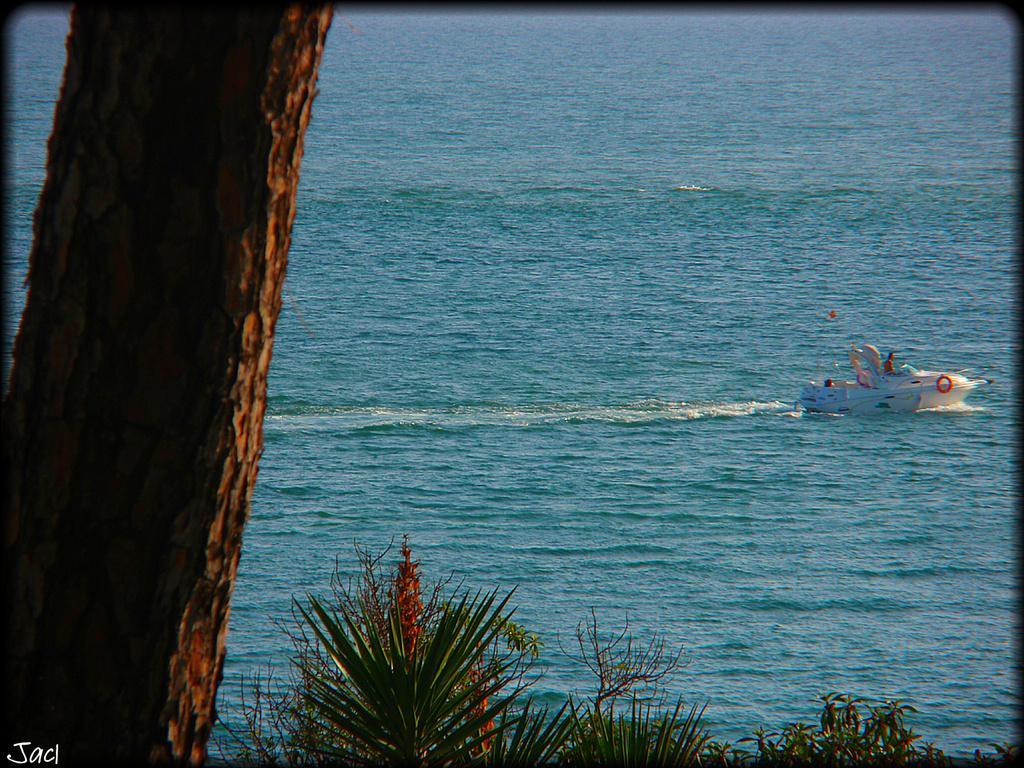In one or two sentences, can you explain what this image depicts? In the image we can see a boat in the water, in the boat there are people sitting. Here we can see a tree trunk, leaves and the sea. On the bottom left we can see watermark. 